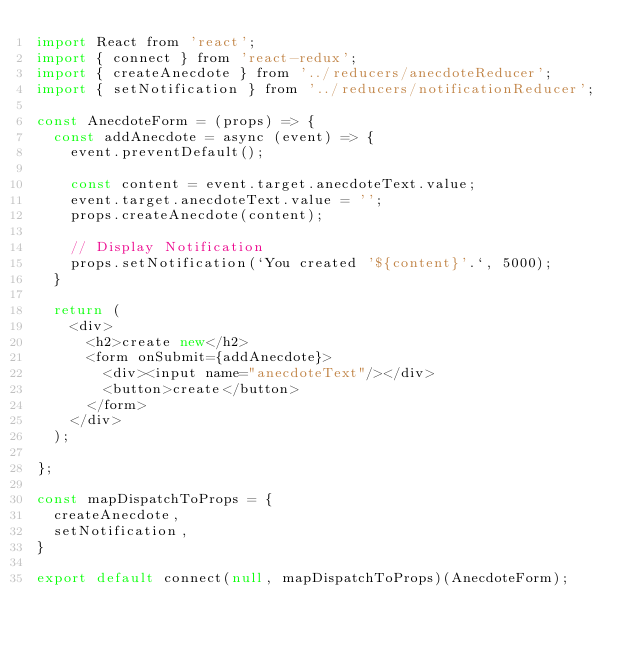Convert code to text. <code><loc_0><loc_0><loc_500><loc_500><_JavaScript_>import React from 'react';
import { connect } from 'react-redux';
import { createAnecdote } from '../reducers/anecdoteReducer';
import { setNotification } from '../reducers/notificationReducer';

const AnecdoteForm = (props) => {
  const addAnecdote = async (event) => {
    event.preventDefault();

    const content = event.target.anecdoteText.value;
    event.target.anecdoteText.value = '';
    props.createAnecdote(content);

    // Display Notification
    props.setNotification(`You created '${content}'.`, 5000);
  }

  return (
    <div>
      <h2>create new</h2>
      <form onSubmit={addAnecdote}>
        <div><input name="anecdoteText"/></div>
        <button>create</button>
      </form>
    </div>
  );

};

const mapDispatchToProps = {
  createAnecdote,
  setNotification,
}

export default connect(null, mapDispatchToProps)(AnecdoteForm);
</code> 